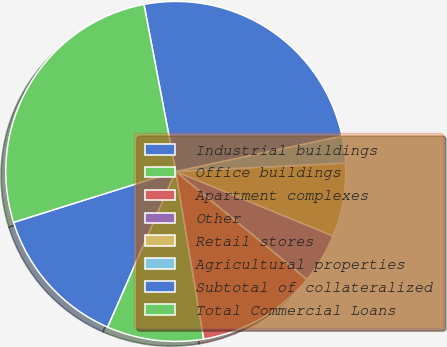Convert chart to OTSL. <chart><loc_0><loc_0><loc_500><loc_500><pie_chart><fcel>Industrial buildings<fcel>Office buildings<fcel>Apartment complexes<fcel>Other<fcel>Retail stores<fcel>Agricultural properties<fcel>Subtotal of collateralized<fcel>Total Commercial Loans<nl><fcel>13.6%<fcel>9.19%<fcel>11.4%<fcel>4.77%<fcel>6.98%<fcel>2.56%<fcel>24.65%<fcel>26.85%<nl></chart> 